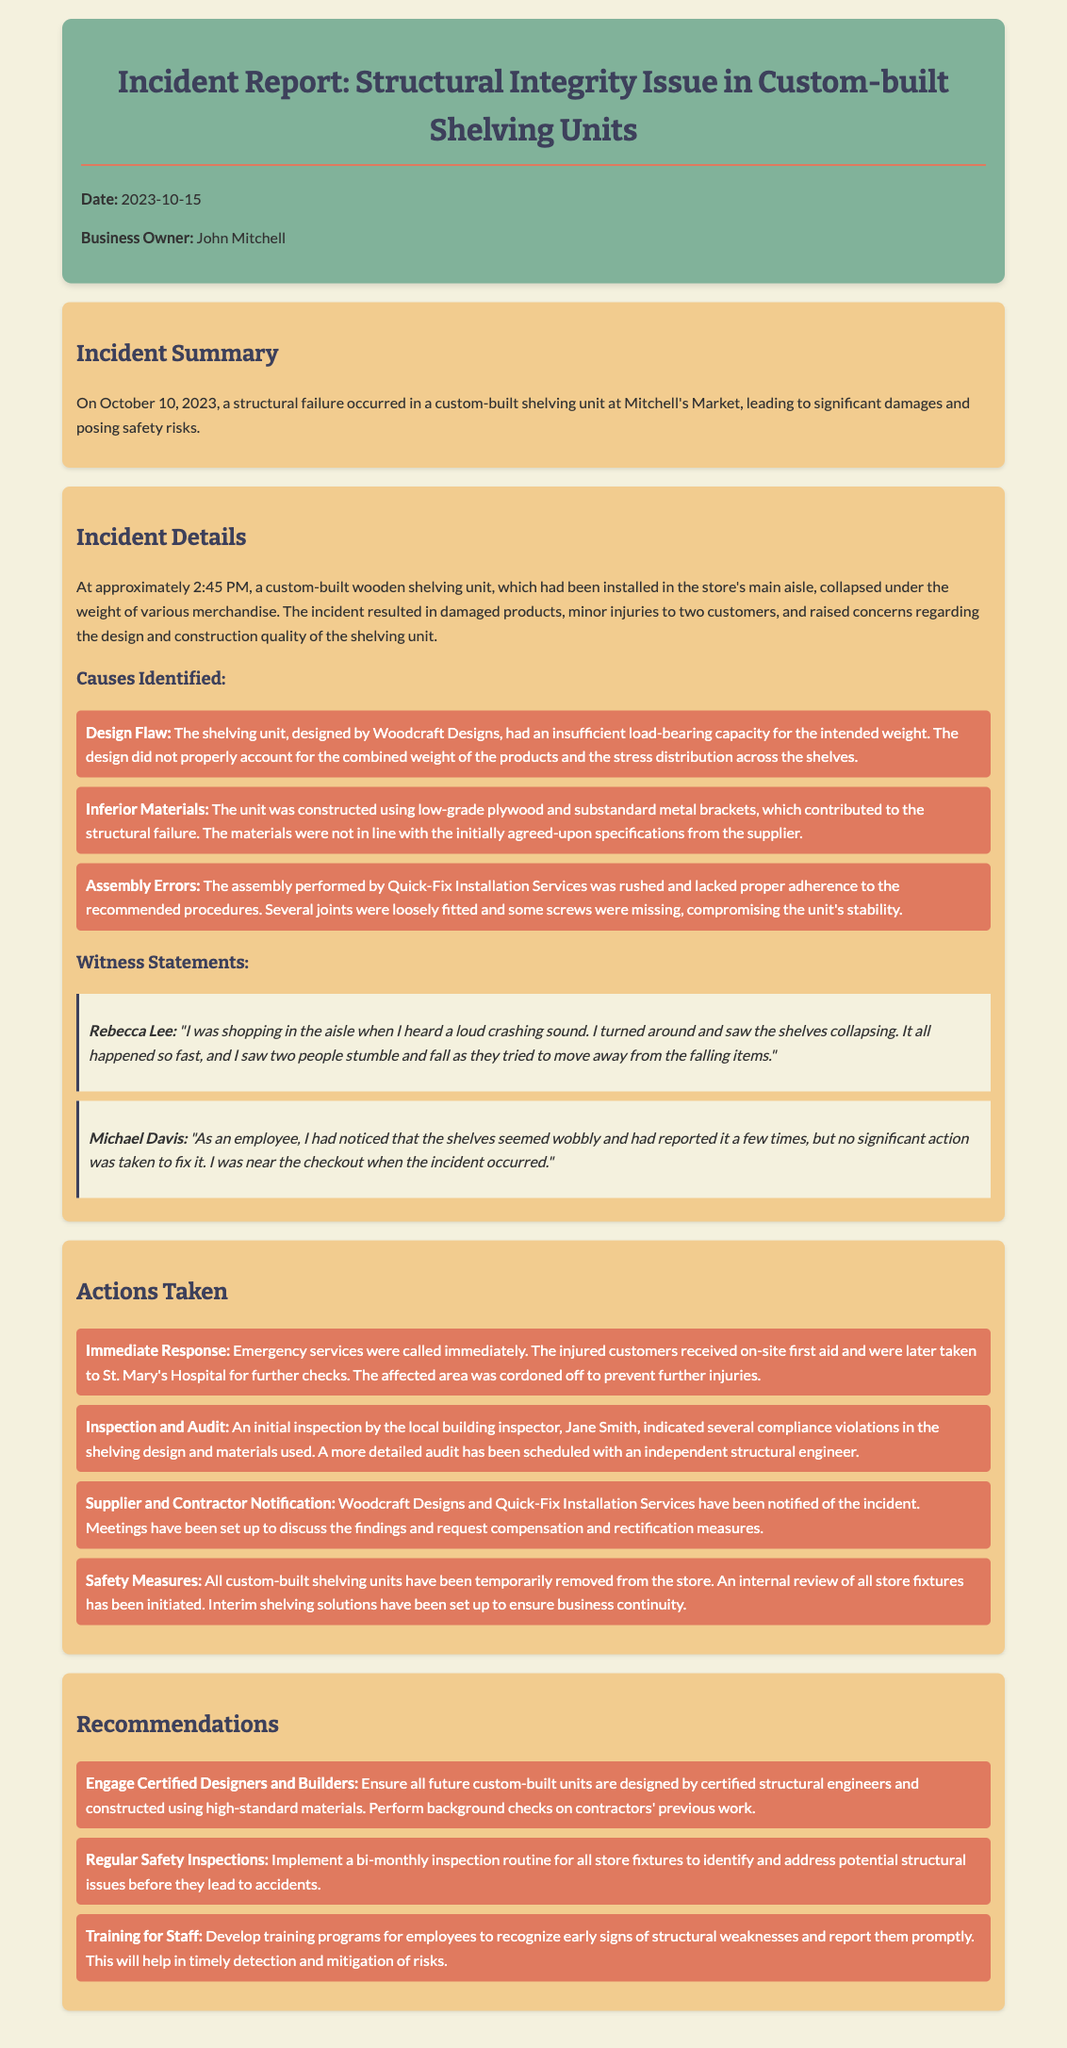what date did the incident occur? The incident occurred on October 10, 2023, as stated in the document.
Answer: October 10, 2023 who is the business owner? The business owner's name is mentioned at the top of the report as John Mitchell.
Answer: John Mitchell what caused the structural failure? The report lists several causes of the disaster, including design flaw, inferior materials, and assembly errors.
Answer: Design Flaw how many customers sustained minor injuries? The document specifies that two customers experienced minor injuries during the incident.
Answer: two who performed the initial inspection? The initial inspection was conducted by the local building inspector named Jane Smith.
Answer: Jane Smith what is one of the recommendations for future custom-built units? The recommendations include engaging certified designers and builders for future construction efforts outlined in the report.
Answer: Engage Certified Designers and Builders when was the incident report created? The report includes the date it was created, which is October 15, 2023.
Answer: October 15, 2023 what type of materials were primarily used in the shelving unit? The document mentions low-grade plywood and substandard metal brackets as the materials used in the construction.
Answer: low-grade plywood what safety measure was taken post-incident? The report states that all custom-built shelving units have been temporarily removed from the store after the incident.
Answer: removed from the store 